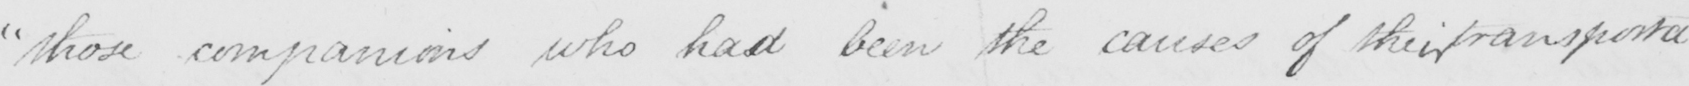Please transcribe the handwritten text in this image. " those companions who had been the causes of their transporta- 